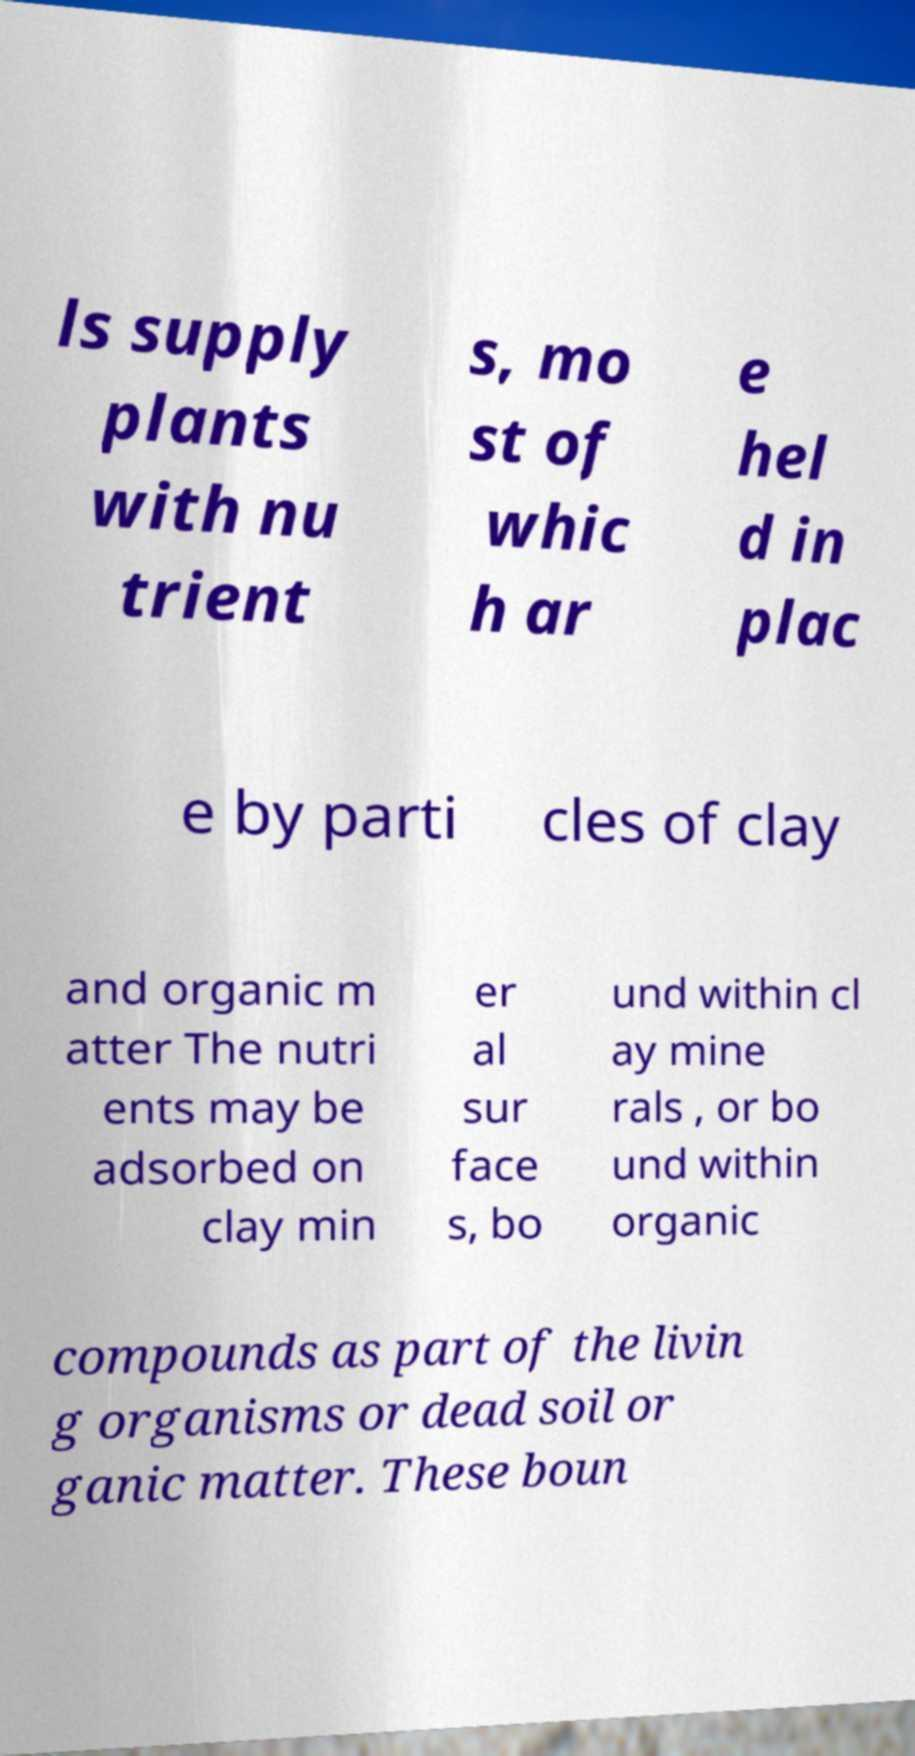There's text embedded in this image that I need extracted. Can you transcribe it verbatim? ls supply plants with nu trient s, mo st of whic h ar e hel d in plac e by parti cles of clay and organic m atter The nutri ents may be adsorbed on clay min er al sur face s, bo und within cl ay mine rals , or bo und within organic compounds as part of the livin g organisms or dead soil or ganic matter. These boun 